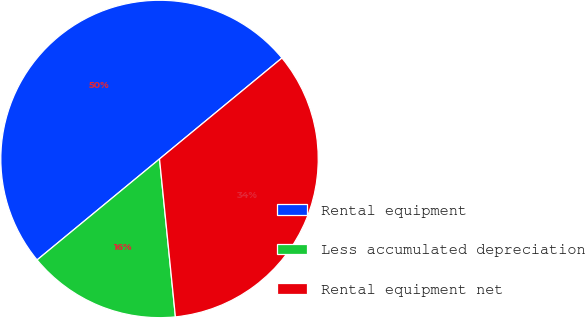Convert chart. <chart><loc_0><loc_0><loc_500><loc_500><pie_chart><fcel>Rental equipment<fcel>Less accumulated depreciation<fcel>Rental equipment net<nl><fcel>50.0%<fcel>15.62%<fcel>34.38%<nl></chart> 